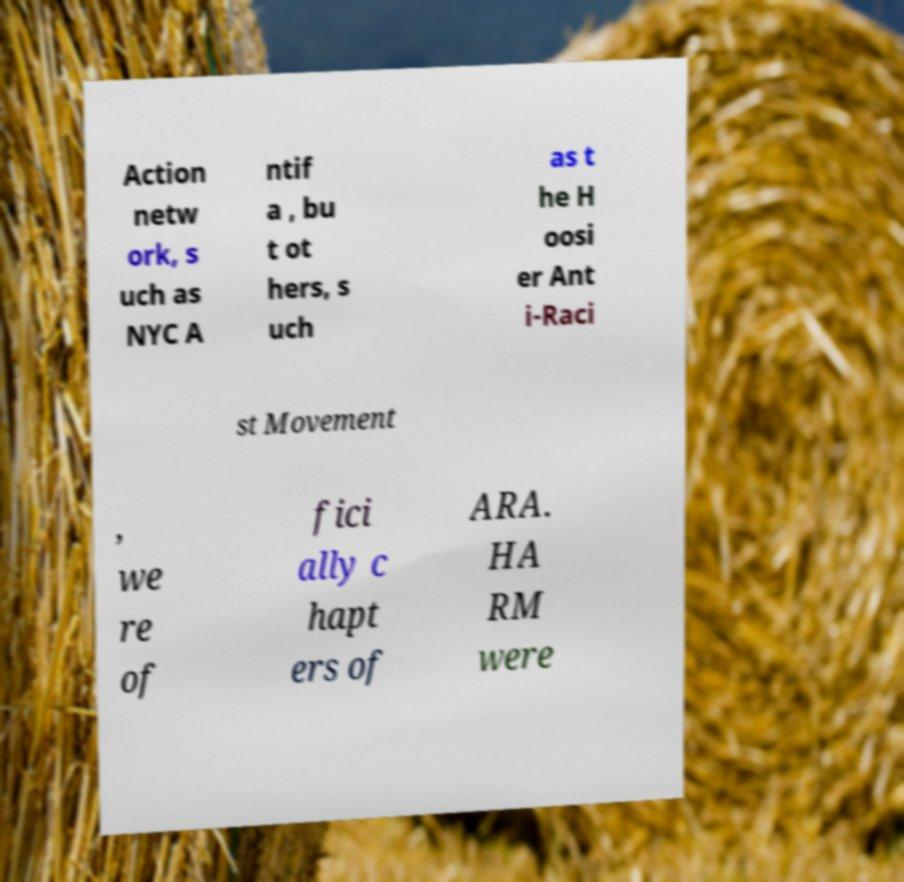For documentation purposes, I need the text within this image transcribed. Could you provide that? Action netw ork, s uch as NYC A ntif a , bu t ot hers, s uch as t he H oosi er Ant i-Raci st Movement , we re of fici ally c hapt ers of ARA. HA RM were 